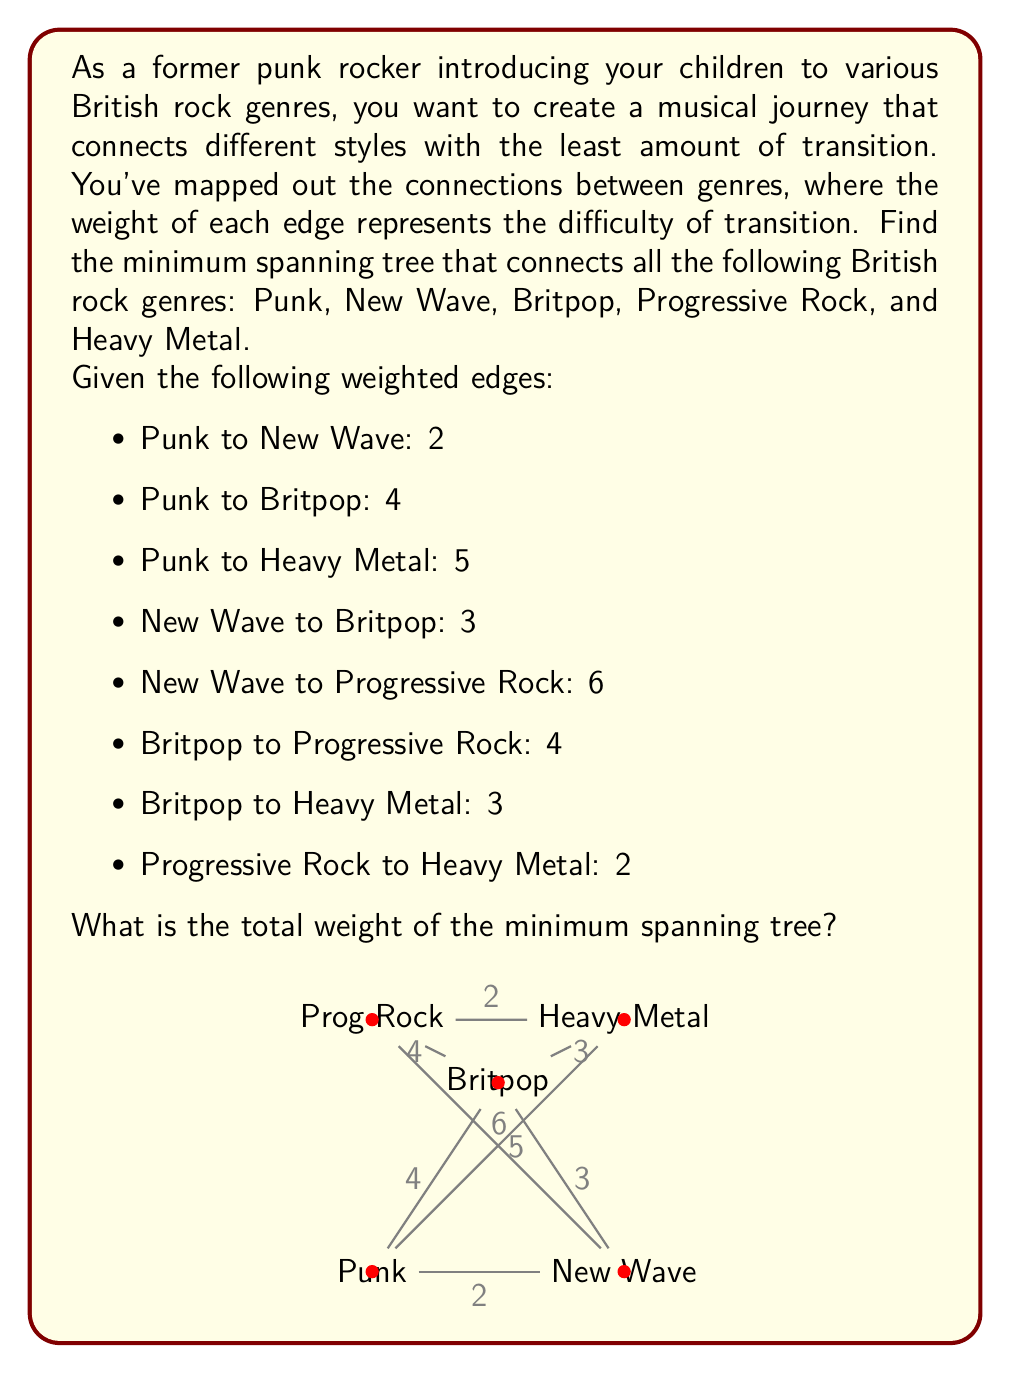Teach me how to tackle this problem. To find the minimum spanning tree, we can use Kruskal's algorithm:

1. Sort all edges by weight in ascending order:
   - Punk to New Wave: 2
   - Progressive Rock to Heavy Metal: 2
   - New Wave to Britpop: 3
   - Britpop to Heavy Metal: 3
   - Punk to Britpop: 4
   - Britpop to Progressive Rock: 4
   - Punk to Heavy Metal: 5
   - New Wave to Progressive Rock: 6

2. Start with an empty set of edges and add edges in order, skipping those that would create a cycle:

   a) Add Punk to New Wave (2)
   b) Add Progressive Rock to Heavy Metal (2)
   c) Add New Wave to Britpop (3)
   d) Skip Britpop to Heavy Metal (would create a cycle)
   e) Skip Punk to Britpop (would create a cycle)
   f) Add Britpop to Progressive Rock (4)

3. We now have a minimum spanning tree connecting all genres:

   Punk -- New Wave -- Britpop -- Progressive Rock -- Heavy Metal

4. Calculate the total weight:
   $2 + 2 + 3 + 4 = 11$

This minimum spanning tree represents the easiest path to introduce your children to all these British rock genres, minimizing the difficulty of transitions between styles.
Answer: The total weight of the minimum spanning tree is 11. 